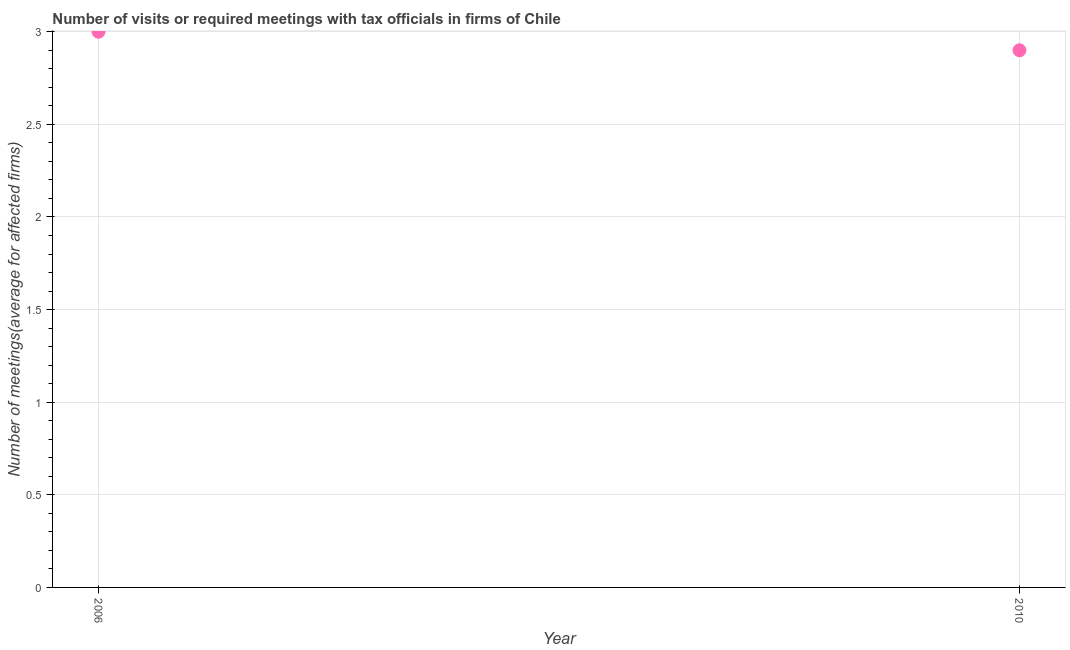Across all years, what is the maximum number of required meetings with tax officials?
Offer a terse response. 3. Across all years, what is the minimum number of required meetings with tax officials?
Offer a very short reply. 2.9. In which year was the number of required meetings with tax officials maximum?
Provide a short and direct response. 2006. In which year was the number of required meetings with tax officials minimum?
Provide a succinct answer. 2010. What is the difference between the number of required meetings with tax officials in 2006 and 2010?
Offer a terse response. 0.1. What is the average number of required meetings with tax officials per year?
Ensure brevity in your answer.  2.95. What is the median number of required meetings with tax officials?
Ensure brevity in your answer.  2.95. In how many years, is the number of required meetings with tax officials greater than 2.9 ?
Keep it short and to the point. 1. What is the ratio of the number of required meetings with tax officials in 2006 to that in 2010?
Ensure brevity in your answer.  1.03. Does the number of required meetings with tax officials monotonically increase over the years?
Your answer should be very brief. No. How many years are there in the graph?
Make the answer very short. 2. Are the values on the major ticks of Y-axis written in scientific E-notation?
Give a very brief answer. No. What is the title of the graph?
Keep it short and to the point. Number of visits or required meetings with tax officials in firms of Chile. What is the label or title of the Y-axis?
Offer a terse response. Number of meetings(average for affected firms). What is the Number of meetings(average for affected firms) in 2006?
Offer a very short reply. 3. What is the ratio of the Number of meetings(average for affected firms) in 2006 to that in 2010?
Provide a short and direct response. 1.03. 